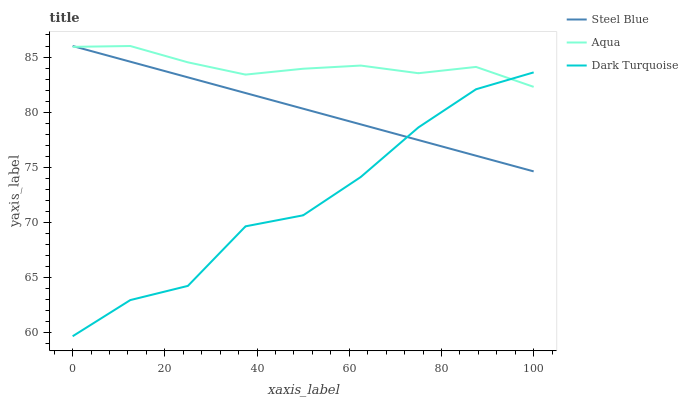Does Steel Blue have the minimum area under the curve?
Answer yes or no. No. Does Steel Blue have the maximum area under the curve?
Answer yes or no. No. Is Aqua the smoothest?
Answer yes or no. No. Is Aqua the roughest?
Answer yes or no. No. Does Steel Blue have the lowest value?
Answer yes or no. No. 